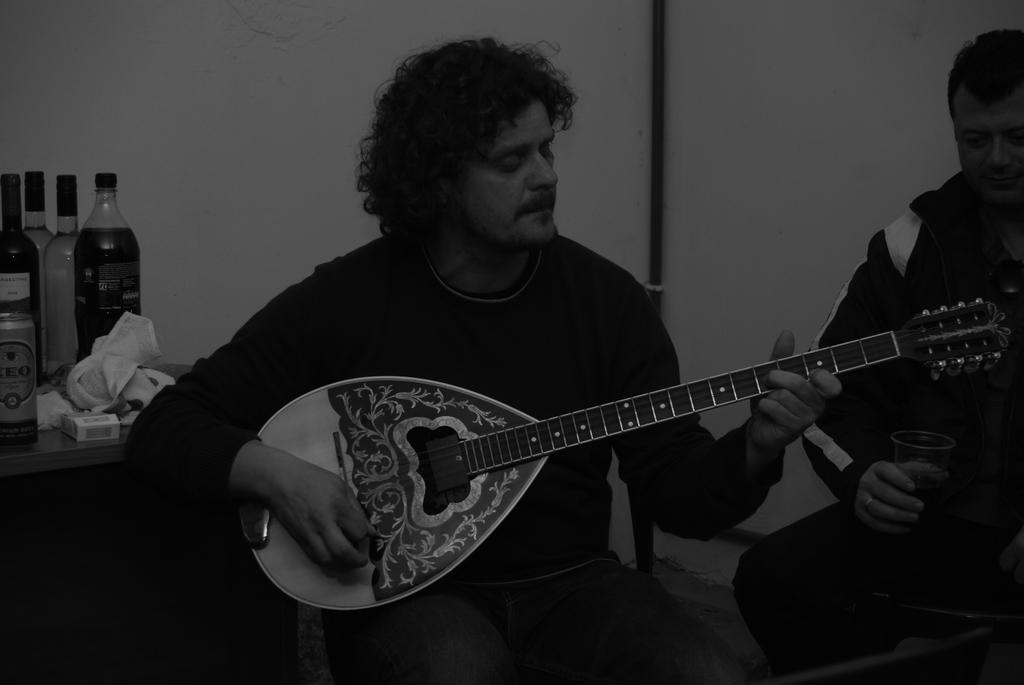Please provide a concise description of this image. As we can see in the image there is a white color wall, man holding guitar and a table. On table there are bottles. 